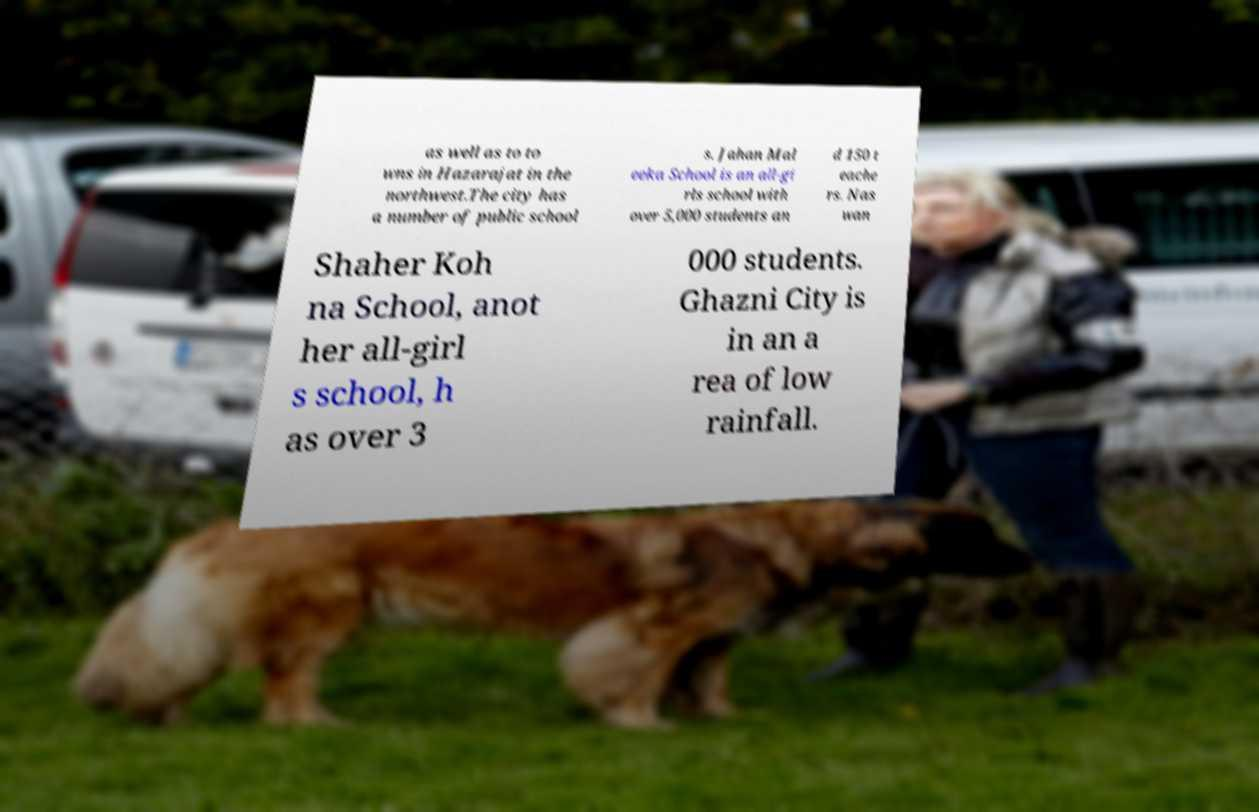For documentation purposes, I need the text within this image transcribed. Could you provide that? as well as to to wns in Hazarajat in the northwest.The city has a number of public school s. Jahan Mal eeka School is an all-gi rls school with over 5,000 students an d 150 t eache rs. Nas wan Shaher Koh na School, anot her all-girl s school, h as over 3 000 students. Ghazni City is in an a rea of low rainfall. 